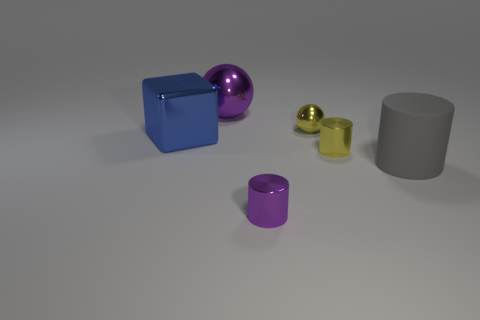What is the color of the metal cylinder in front of the yellow thing in front of the blue shiny block?
Provide a short and direct response. Purple. There is another purple object that is the same shape as the matte object; what is it made of?
Make the answer very short. Metal. What number of purple rubber objects are the same size as the yellow ball?
Offer a very short reply. 0. There is a blue block that is the same material as the yellow cylinder; what size is it?
Your response must be concise. Large. What number of other small things have the same shape as the blue metallic thing?
Ensure brevity in your answer.  0. How many red matte blocks are there?
Provide a succinct answer. 0. Do the tiny purple thing that is in front of the purple ball and the big matte object have the same shape?
Your response must be concise. Yes. What material is the purple cylinder that is the same size as the yellow metal cylinder?
Offer a very short reply. Metal. Are there any tiny purple objects made of the same material as the blue cube?
Your answer should be very brief. Yes. There is a big blue shiny object; is its shape the same as the big rubber thing on the right side of the cube?
Keep it short and to the point. No. 